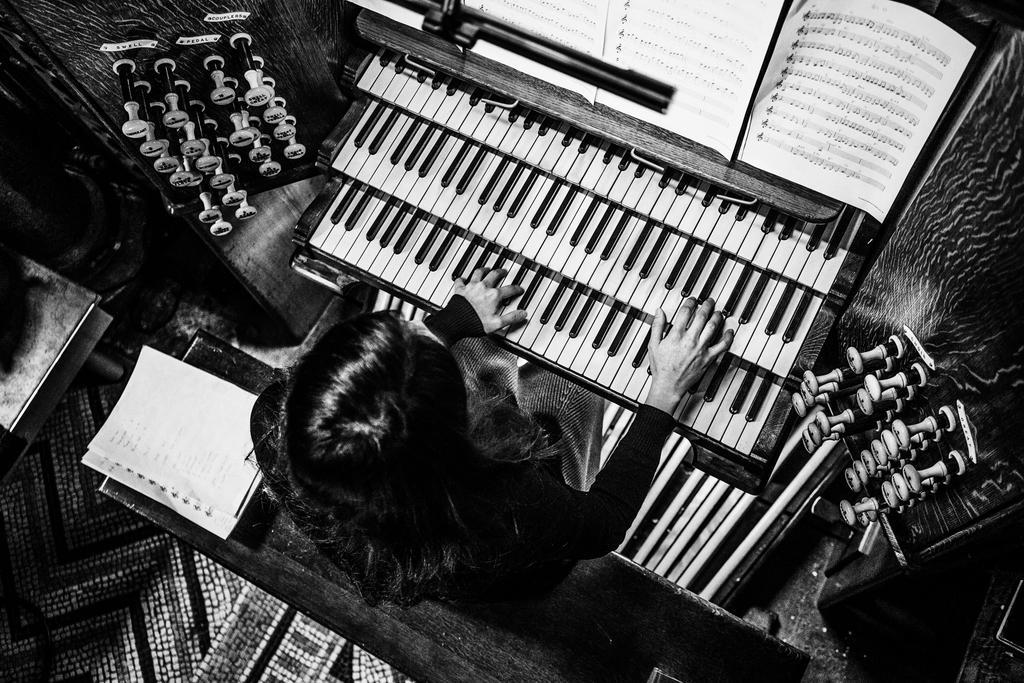In one or two sentences, can you explain what this image depicts? In this picture a lady is playing a piano with books of tubes attached to it. 